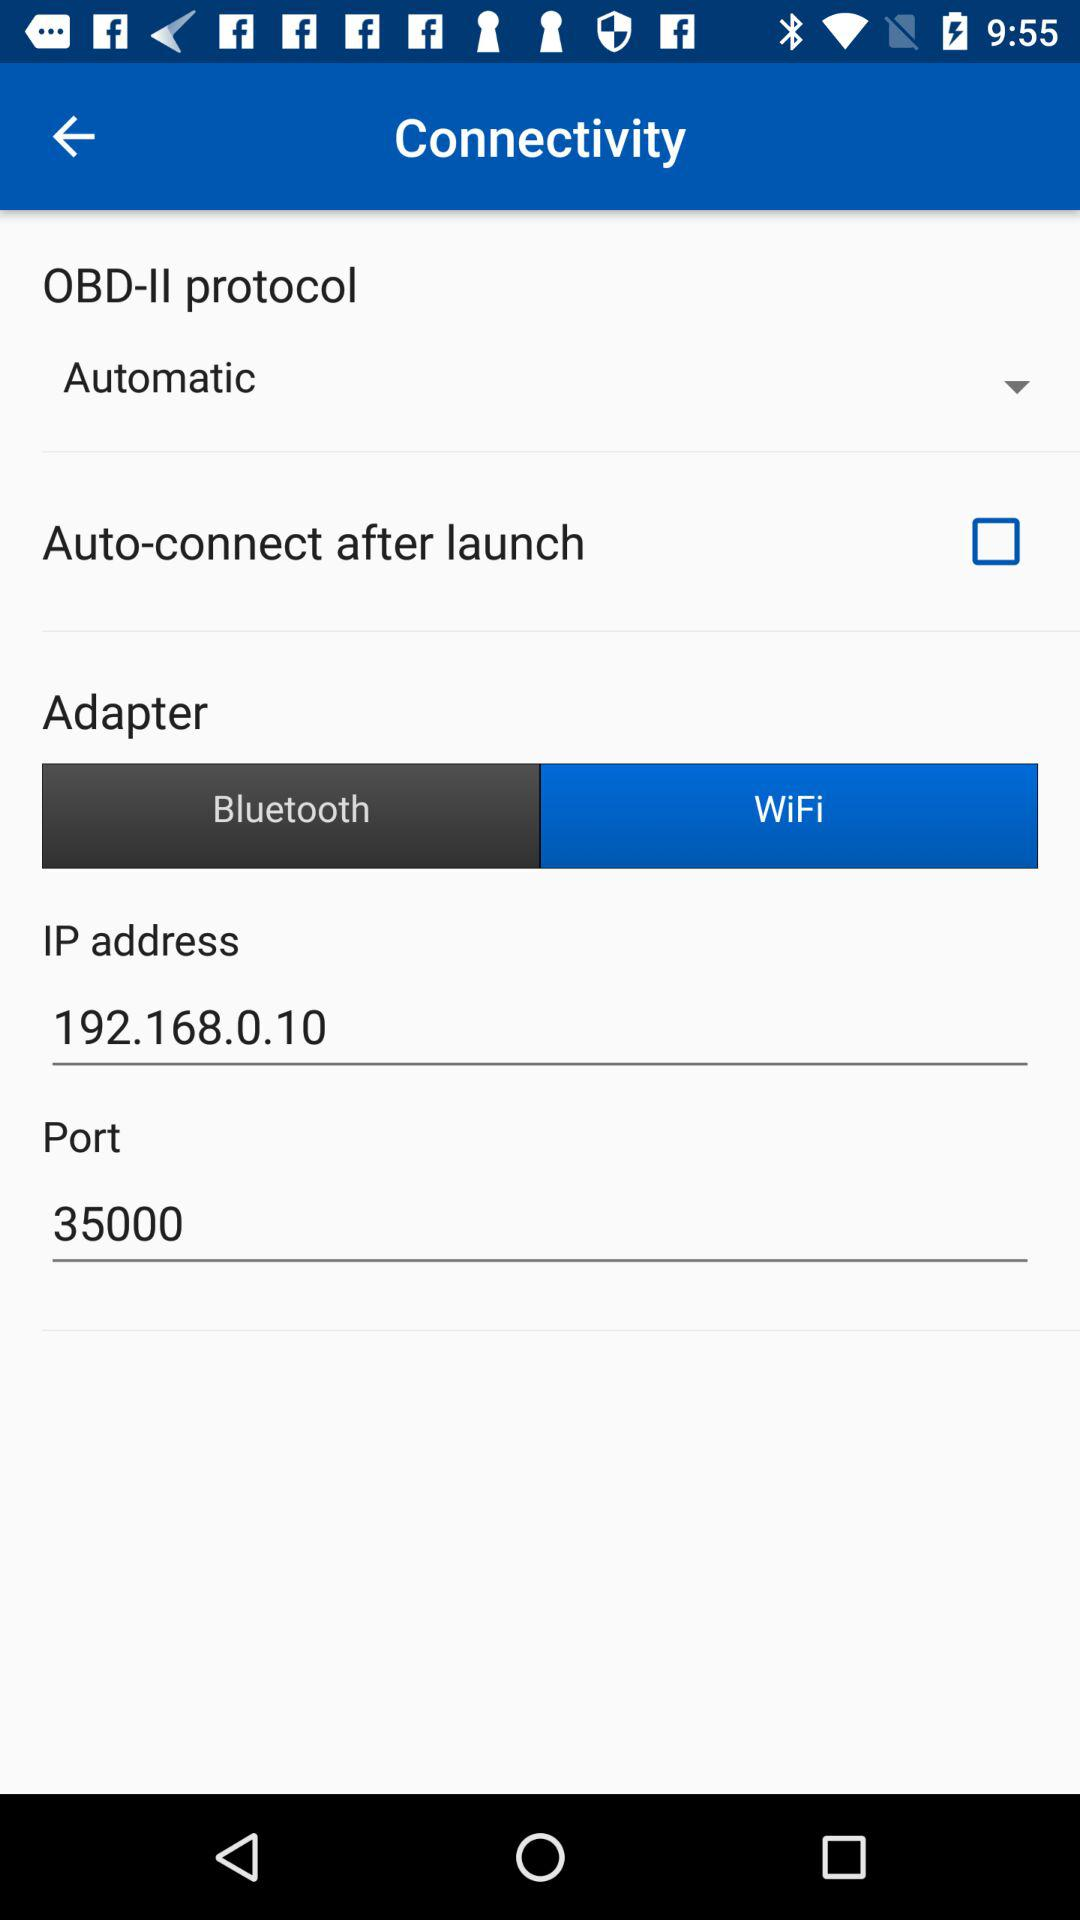What is the setting for OBD-II protocol? The setting is "Automatic". 